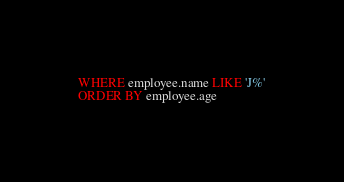Convert code to text. <code><loc_0><loc_0><loc_500><loc_500><_SQL_>WHERE employee.name LIKE 'J%'
ORDER BY employee.age
</code> 